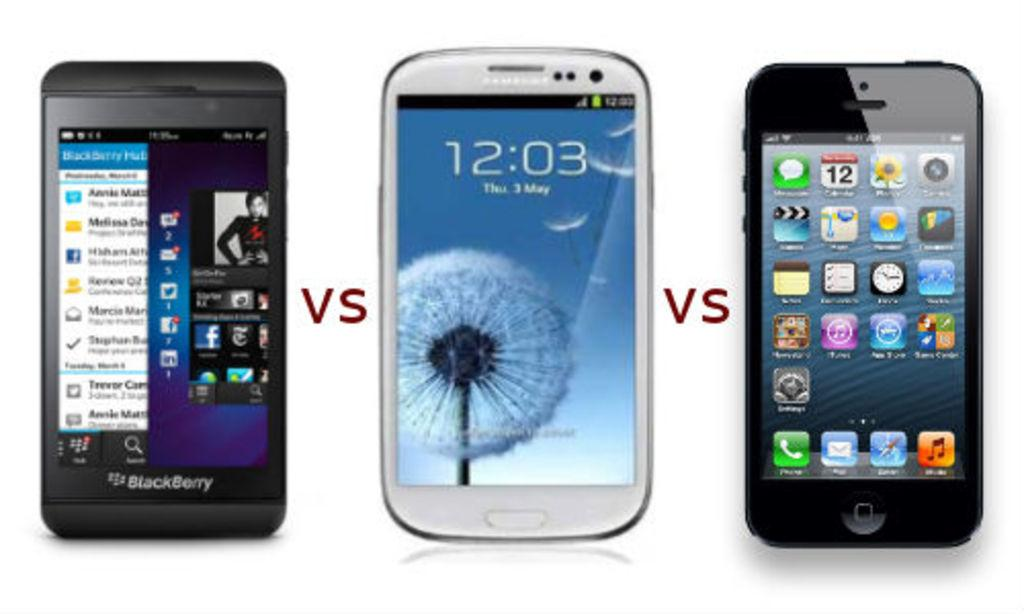<image>
Present a compact description of the photo's key features. A blackberry vs Samsung vs Iphone phone model is displayed 